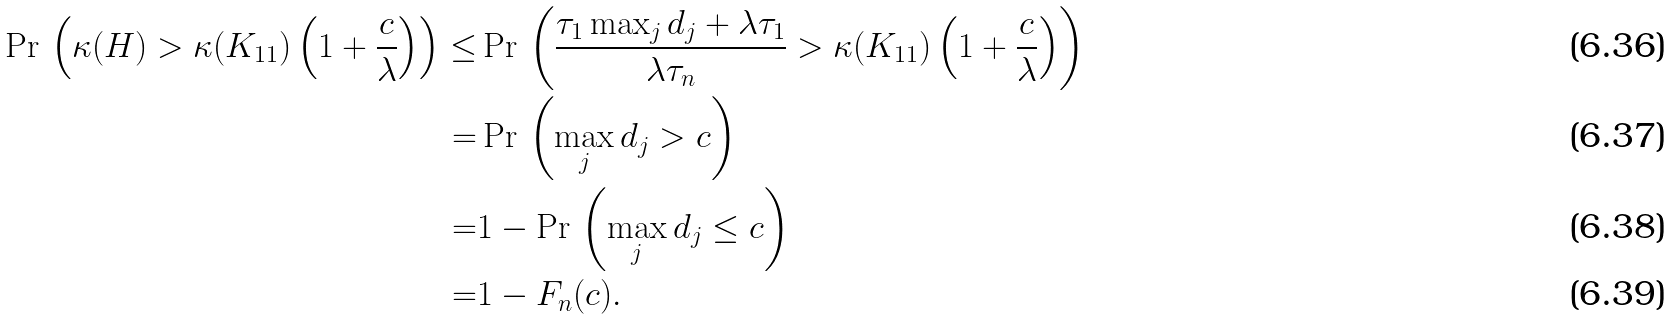<formula> <loc_0><loc_0><loc_500><loc_500>\Pr \, \left ( \kappa ( H ) > \kappa ( K _ { 1 1 } ) \left ( 1 + \frac { c } { \lambda } \right ) \right ) \leq & \Pr \, \left ( \frac { \tau _ { 1 } \max _ { j } d _ { j } + \lambda \tau _ { 1 } } { \lambda \tau _ { n } } > \kappa ( K _ { 1 1 } ) \left ( 1 + \frac { c } { \lambda } \right ) \right ) \\ = & \Pr \, \left ( \max _ { j } d _ { j } > c \right ) \\ = & 1 - \Pr \, \left ( \max _ { j } d _ { j } \leq c \right ) \\ = & 1 - F _ { n } ( c ) .</formula> 